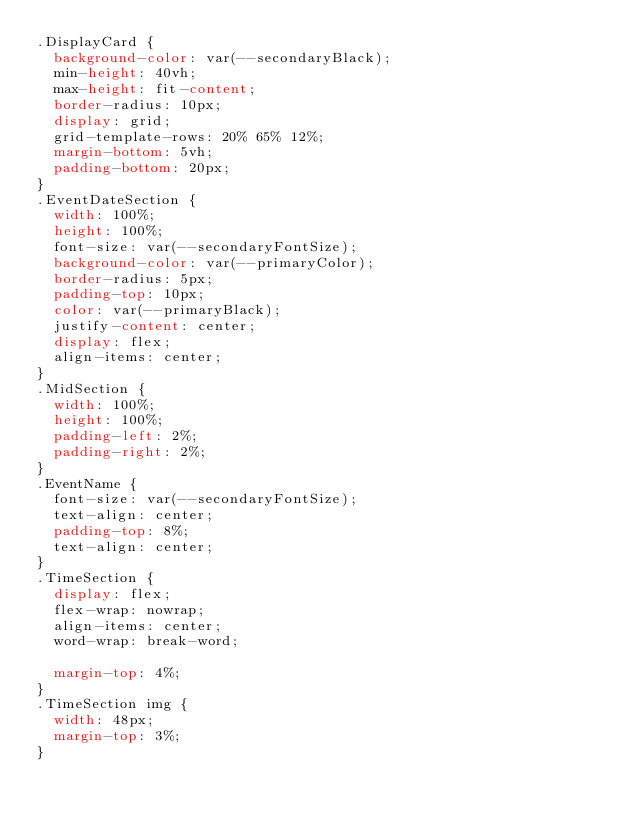<code> <loc_0><loc_0><loc_500><loc_500><_CSS_>.DisplayCard {
  background-color: var(--secondaryBlack);
  min-height: 40vh;
  max-height: fit-content;
  border-radius: 10px;
  display: grid;
  grid-template-rows: 20% 65% 12%;
  margin-bottom: 5vh;
  padding-bottom: 20px;
}
.EventDateSection {
  width: 100%;
  height: 100%;
  font-size: var(--secondaryFontSize);
  background-color: var(--primaryColor);
  border-radius: 5px;
  padding-top: 10px;
  color: var(--primaryBlack);
  justify-content: center;
  display: flex;
  align-items: center;
}
.MidSection {
  width: 100%;
  height: 100%;
  padding-left: 2%;
  padding-right: 2%;
}
.EventName {
  font-size: var(--secondaryFontSize);
  text-align: center;
  padding-top: 8%;
  text-align: center;
}
.TimeSection {
  display: flex;
  flex-wrap: nowrap;
  align-items: center;
  word-wrap: break-word;

  margin-top: 4%;
}
.TimeSection img {
  width: 48px;
  margin-top: 3%;
}</code> 